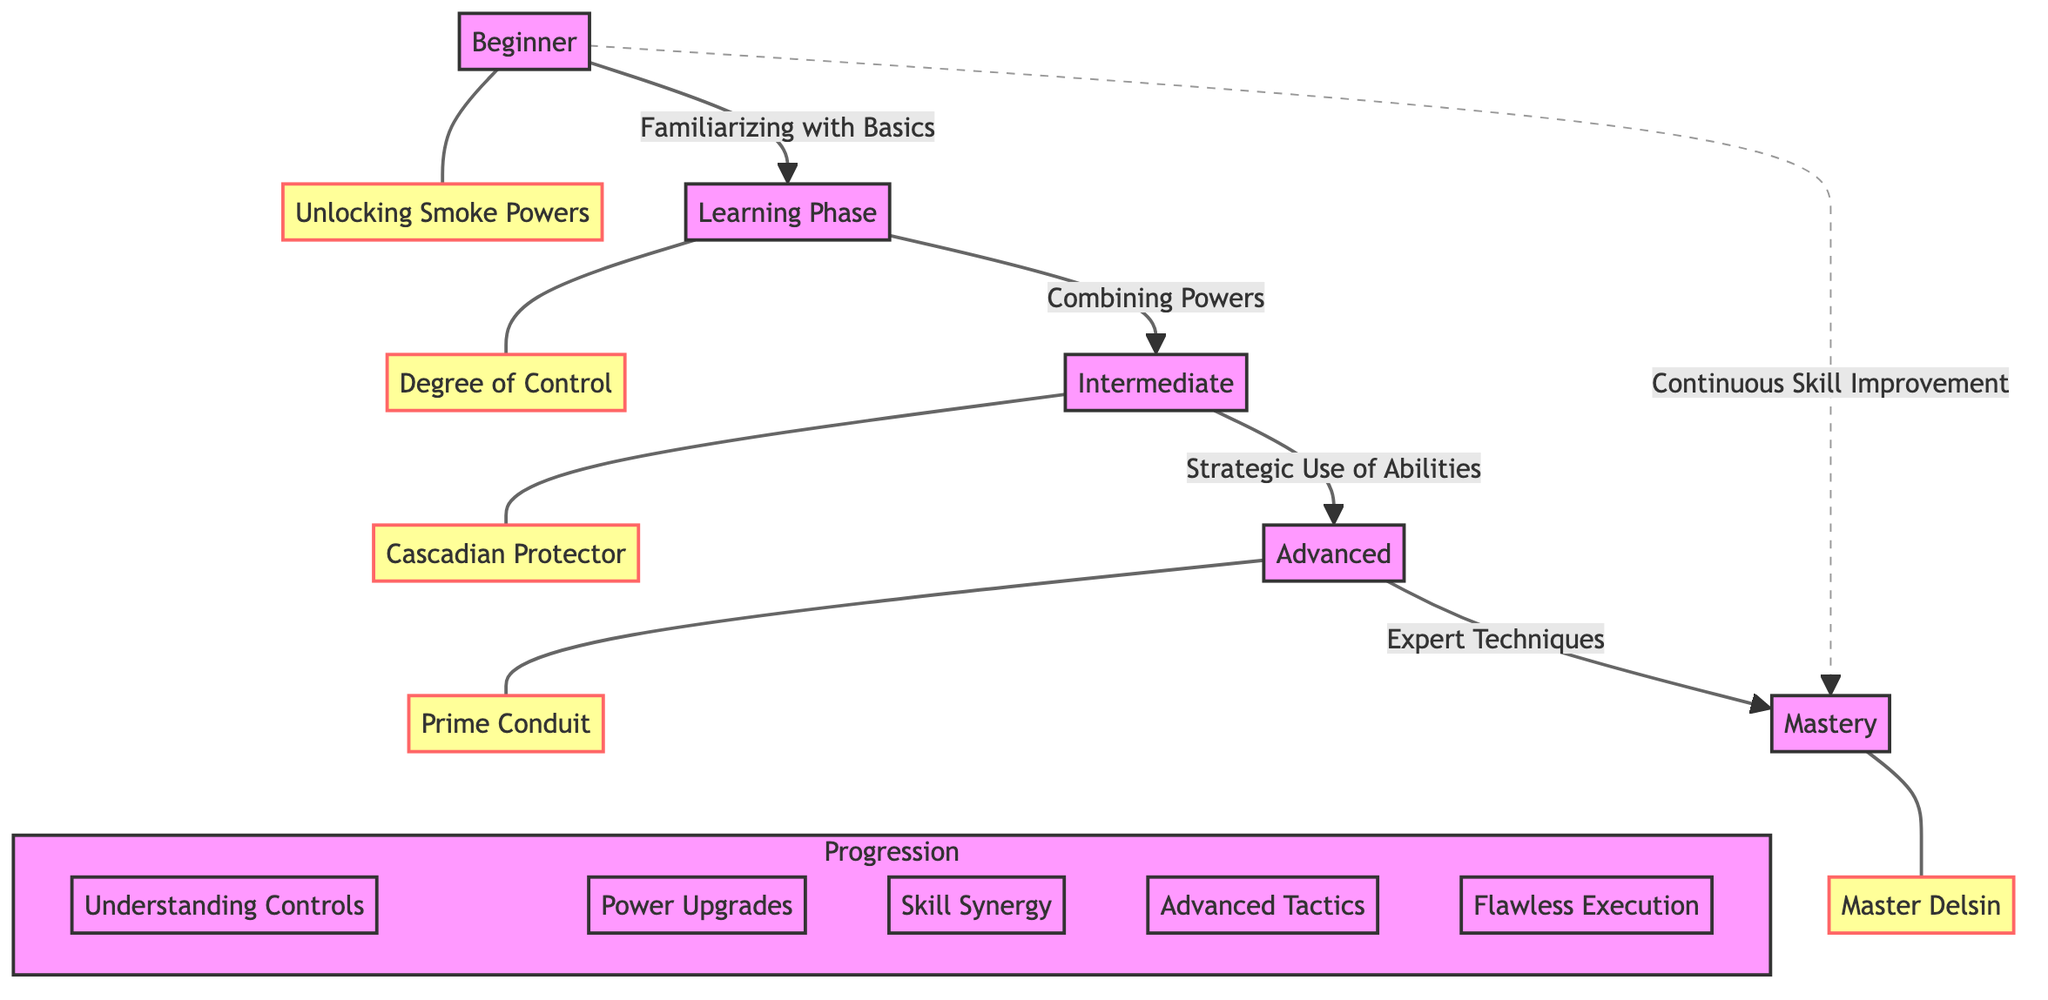What is the first stage of player skill evolution? The diagram shows "Beginner" as the first node in the player skill evolution progression, indicating the initial stage of a player's journey.
Answer: Beginner How many milestones are represented in the diagram? By counting the nodes labeled as milestones (M1 to M5), there are five distinct milestones depicted in the diagram.
Answer: 5 What skill level is achieved after the "Learning Phase"? The diagram indicates that the progression leads from the "Learning Phase" directly to the "Intermediate" skill level, which is the next step following learning fundamentals.
Answer: Intermediate Which milestone corresponds to the "Advanced" skill level? The diagram assigns the milestone labeled "Prime Conduit" (M4) to the "Advanced" skill level, showing a significant achievement in skill development.
Answer: Prime Conduit What is the final milestone in the player's skill evolution? The diagram shows "Master Delsin" (M5) as the last milestone, signifying the pinnacle of player skill evolution.
Answer: Master Delsin Which node represents the concept of combining powers? The flow leads from the node "Learning Phase" to the node "Intermediate", where "Combining Powers" is specifically mentioned, identifying the stage when players learn this skill.
Answer: Combining Powers What does the dashed line between "Advanced" and "Mastery" signify? The dashed line indicates a non-linear progression with "Continuous Skill Improvement", showing that a player can improve their skills even while mastering abilities.
Answer: Continuous Skill Improvement How many nodes are there in total in the skill evolution progression? The diagram includes five skill levels (Beginner, Learning Phase, Intermediate, Advanced, Mastery), one node for continuous improvement, and five milestone nodes, totaling eleven nodes.
Answer: 11 What is the connection between "Intermediate" and "Advanced"? The "Intermediate" level is directly connected to the "Advanced" level through the action of "Strategic Use of Abilities", indicating the transition based on skill development in using tactics.
Answer: Strategic Use of Abilities 